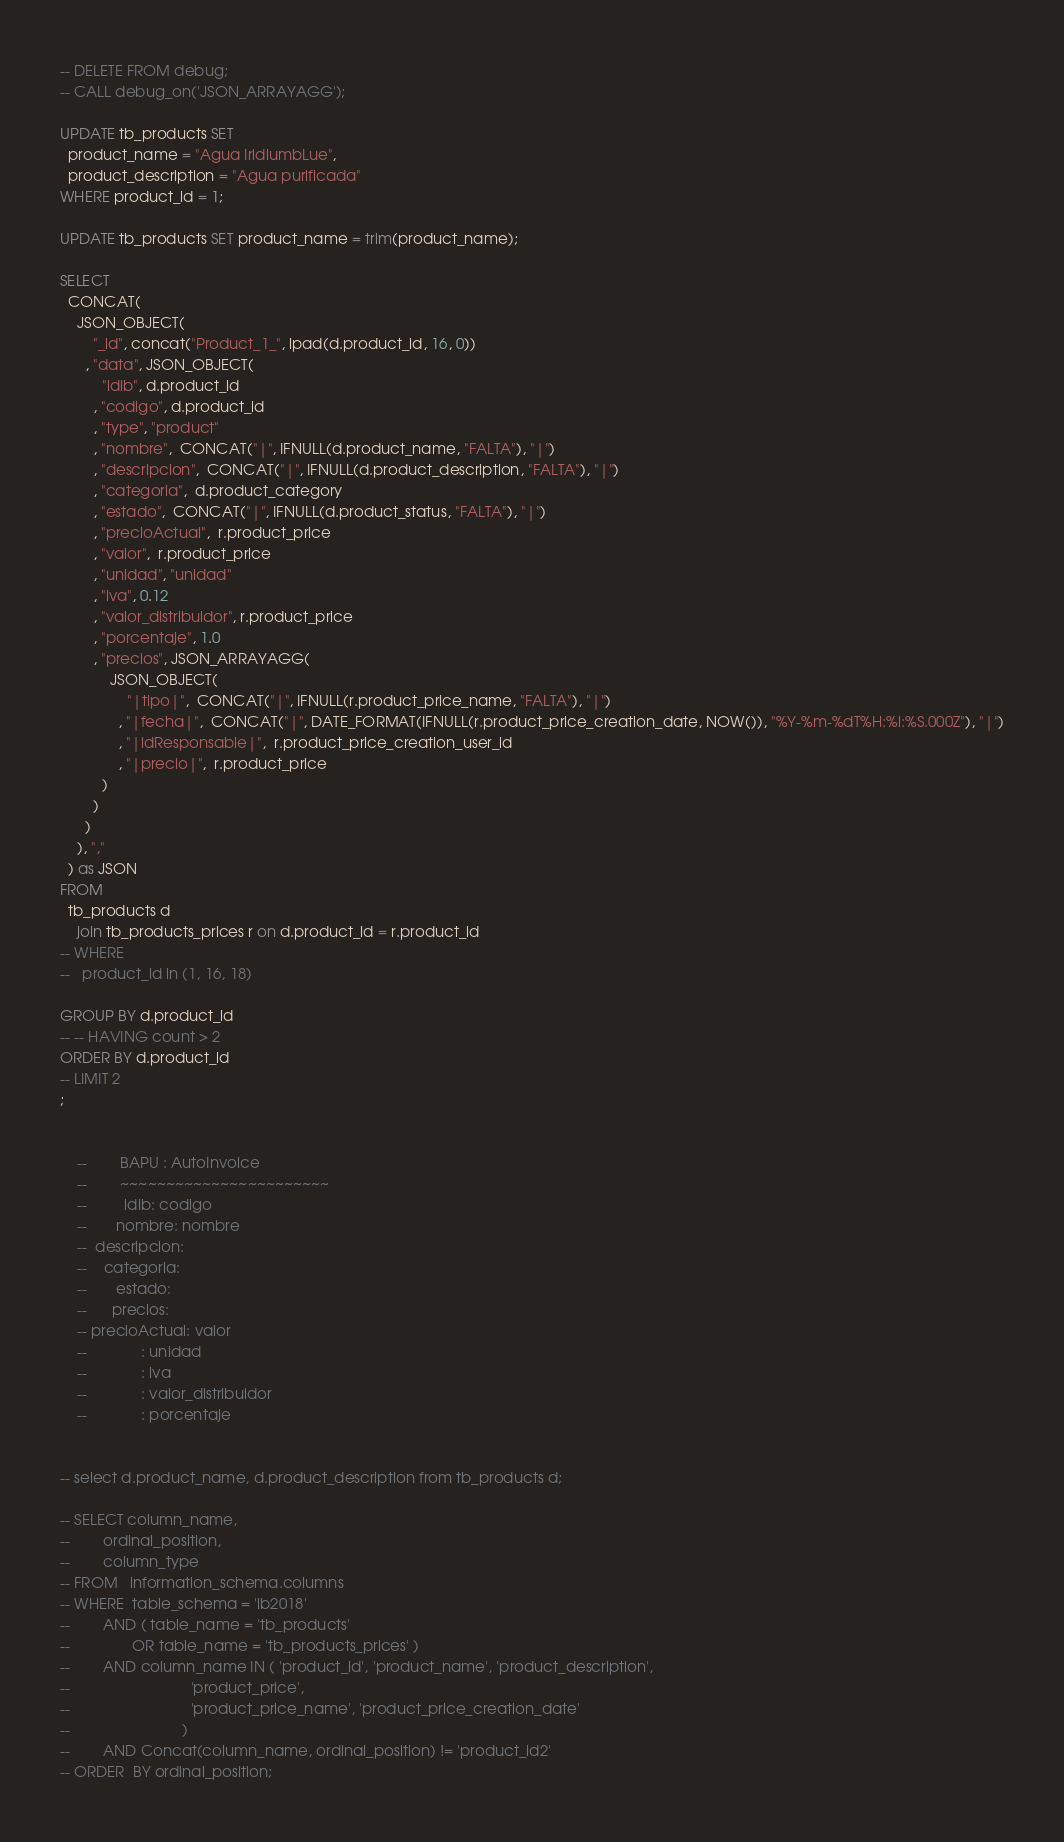<code> <loc_0><loc_0><loc_500><loc_500><_SQL_>-- DELETE FROM debug;
-- CALL debug_on('JSON_ARRAYAGG');

UPDATE tb_products SET
  product_name = "Agua IridiumbLue",
  product_description = "Agua purificada"
WHERE product_id = 1;

UPDATE tb_products SET product_name = trim(product_name);

SELECT
  CONCAT(
    JSON_OBJECT(
        "_id", concat("Product_1_", lpad(d.product_id, 16, 0))
      , "data", JSON_OBJECT(
          "idib", d.product_id
        , "codigo", d.product_id
        , "type", "product"
        , "nombre",  CONCAT("|", IFNULL(d.product_name, "FALTA"), "|")
        , "descripcion",  CONCAT("|", IFNULL(d.product_description, "FALTA"), "|")
        , "categoria",  d.product_category
        , "estado",  CONCAT("|", IFNULL(d.product_status, "FALTA"), "|")
        , "precioActual",  r.product_price
        , "valor",  r.product_price
        , "unidad", "unidad"
        , "iva", 0.12
        , "valor_distribuidor", r.product_price
        , "porcentaje", 1.0
        , "precios", JSON_ARRAYAGG(
            JSON_OBJECT(
                "|tipo|",  CONCAT("|", IFNULL(r.product_price_name, "FALTA"), "|")
              , "|fecha|",  CONCAT("|", DATE_FORMAT(IFNULL(r.product_price_creation_date, NOW()), "%Y-%m-%dT%H:%i:%S.000Z"), "|")
              , "|idResponsable|",  r.product_price_creation_user_id
              , "|precio|",  r.product_price
          )
        )
      )
    ), ","
  ) as JSON
FROM
  tb_products d
    join tb_products_prices r on d.product_id = r.product_id
-- WHERE
--   product_id in (1, 16, 18)

GROUP BY d.product_id
-- -- HAVING count > 2
ORDER BY d.product_id
-- LIMIT 2
;


    --        BAPU : AutoInvoice
    --        ~~~~~~~~~~~~~~~~~~~~~~~
    --         idib: codigo
    --       nombre: nombre
    --  descripcion:
    --    categoria:
    --       estado:
    --      precios:
    -- precioActual: valor
    --             : unidad
    --             : iva
    --             : valor_distribuidor
    --             : porcentaje


-- select d.product_name, d.product_description from tb_products d;

-- SELECT column_name,
--        ordinal_position,
--        column_type
-- FROM   information_schema.columns
-- WHERE  table_schema = 'ib2018'
--        AND ( table_name = 'tb_products'
--               OR table_name = 'tb_products_prices' )
--        AND column_name IN ( 'product_id', 'product_name', 'product_description',
--                             'product_price',
--                             'product_price_name', 'product_price_creation_date'
--                           )
--        AND Concat(column_name, ordinal_position) != 'product_id2'
-- ORDER  BY ordinal_position;
</code> 